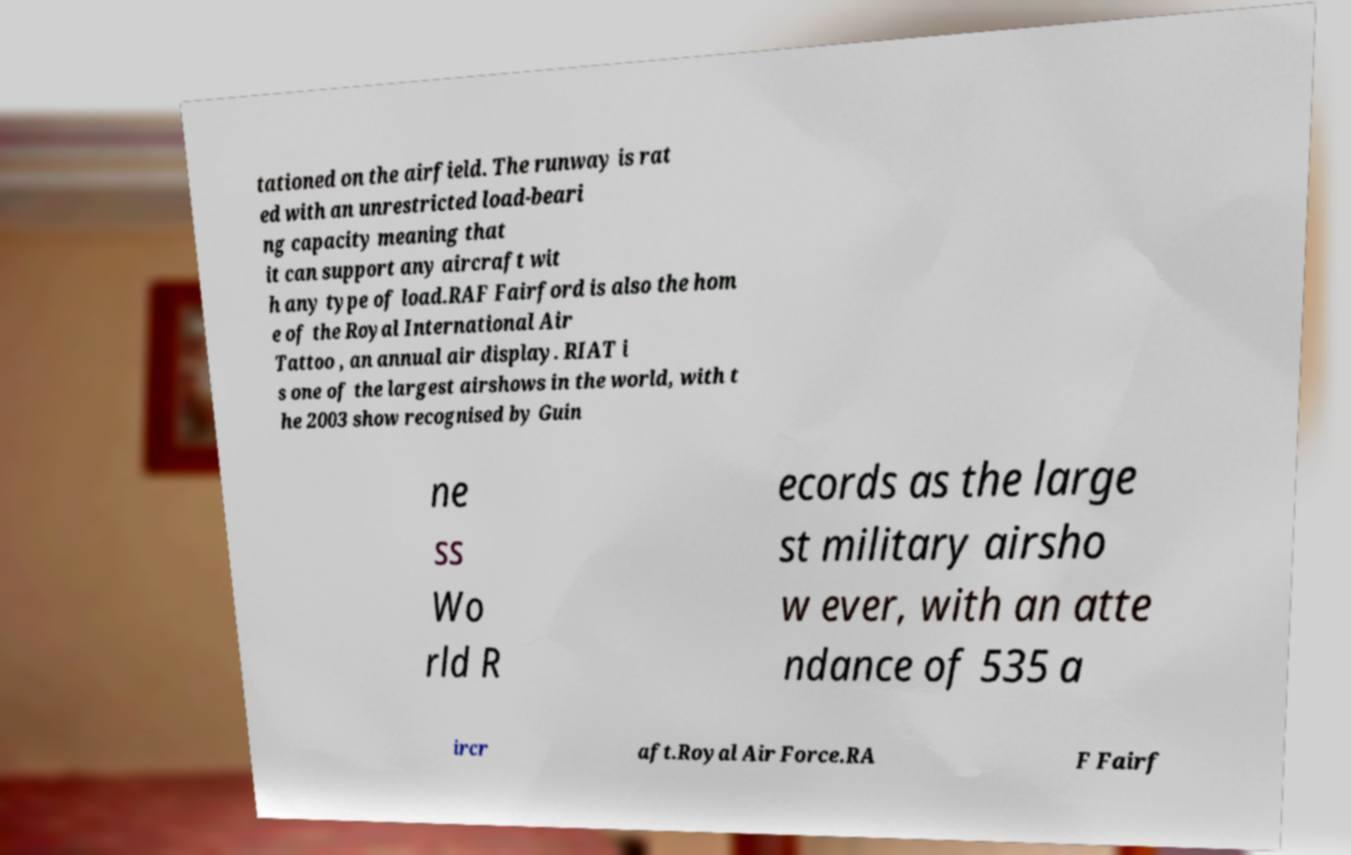I need the written content from this picture converted into text. Can you do that? tationed on the airfield. The runway is rat ed with an unrestricted load-beari ng capacity meaning that it can support any aircraft wit h any type of load.RAF Fairford is also the hom e of the Royal International Air Tattoo , an annual air display. RIAT i s one of the largest airshows in the world, with t he 2003 show recognised by Guin ne ss Wo rld R ecords as the large st military airsho w ever, with an atte ndance of 535 a ircr aft.Royal Air Force.RA F Fairf 